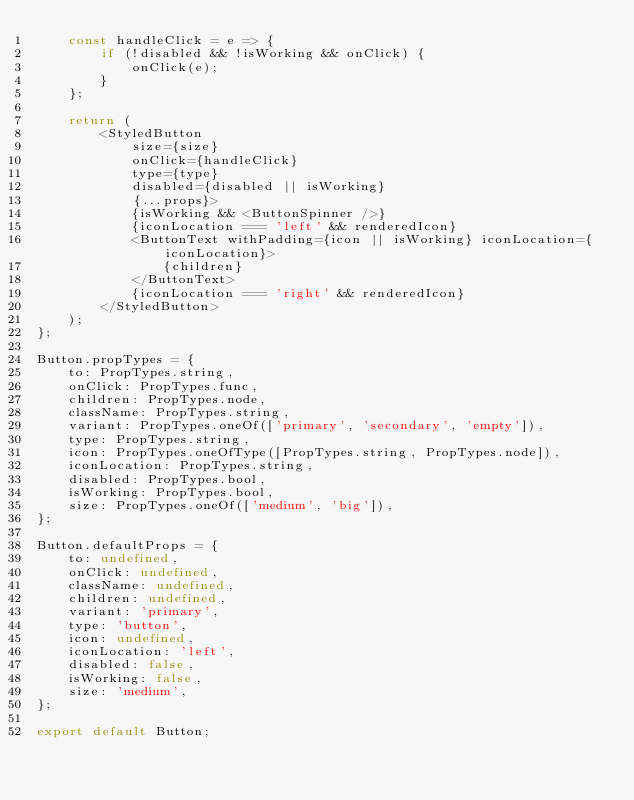<code> <loc_0><loc_0><loc_500><loc_500><_JavaScript_>    const handleClick = e => {
        if (!disabled && !isWorking && onClick) {
            onClick(e);
        }
    };

    return (
        <StyledButton
            size={size}
            onClick={handleClick}
            type={type}
            disabled={disabled || isWorking}
            {...props}>
            {isWorking && <ButtonSpinner />}
            {iconLocation === 'left' && renderedIcon}
            <ButtonText withPadding={icon || isWorking} iconLocation={iconLocation}>
                {children}
            </ButtonText>
            {iconLocation === 'right' && renderedIcon}
        </StyledButton>
    );
};

Button.propTypes = {
    to: PropTypes.string,
    onClick: PropTypes.func,
    children: PropTypes.node,
    className: PropTypes.string,
    variant: PropTypes.oneOf(['primary', 'secondary', 'empty']),
    type: PropTypes.string,
    icon: PropTypes.oneOfType([PropTypes.string, PropTypes.node]),
    iconLocation: PropTypes.string,
    disabled: PropTypes.bool,
    isWorking: PropTypes.bool,
    size: PropTypes.oneOf(['medium', 'big']),
};

Button.defaultProps = {
    to: undefined,
    onClick: undefined,
    className: undefined,
    children: undefined,
    variant: 'primary',
    type: 'button',
    icon: undefined,
    iconLocation: 'left',
    disabled: false,
    isWorking: false,
    size: 'medium',
};

export default Button;
</code> 